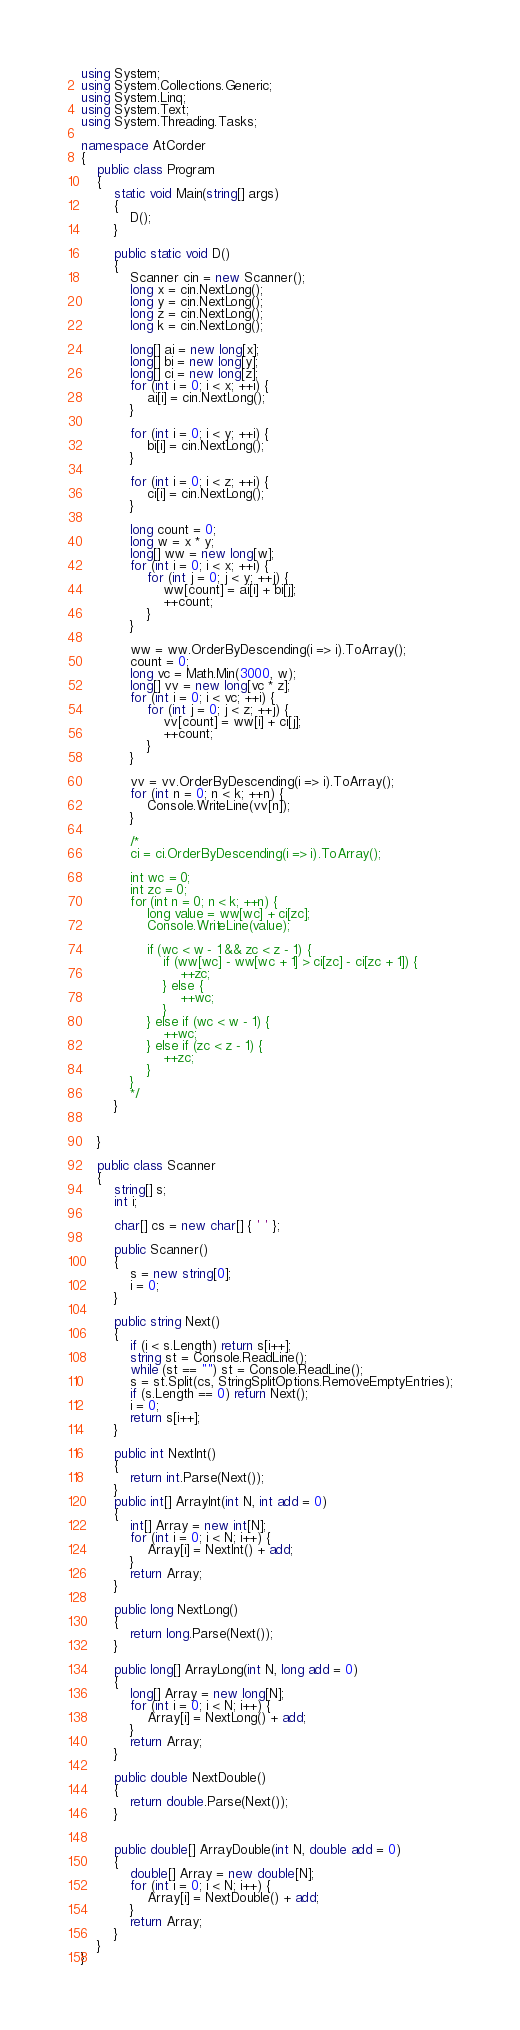Convert code to text. <code><loc_0><loc_0><loc_500><loc_500><_C#_>using System;
using System.Collections.Generic;
using System.Linq;
using System.Text;
using System.Threading.Tasks;

namespace AtCorder
{
	public class Program
	{
		static void Main(string[] args)
		{
			D();
		}

		public static void D()
		{
			Scanner cin = new Scanner();
			long x = cin.NextLong();
			long y = cin.NextLong();
			long z = cin.NextLong();
			long k = cin.NextLong();

			long[] ai = new long[x];
			long[] bi = new long[y];
			long[] ci = new long[z];
			for (int i = 0; i < x; ++i) {
				ai[i] = cin.NextLong();
			}

			for (int i = 0; i < y; ++i) {
				bi[i] = cin.NextLong();
			}

			for (int i = 0; i < z; ++i) {
				ci[i] = cin.NextLong();
			}

			long count = 0;
			long w = x * y;
			long[] ww = new long[w];
			for (int i = 0; i < x; ++i) {
				for (int j = 0; j < y; ++j) {
					ww[count] = ai[i] + bi[j];
					++count;
				}
			}

			ww = ww.OrderByDescending(i => i).ToArray();
			count = 0;
			long vc = Math.Min(3000, w);
			long[] vv = new long[vc * z];
			for (int i = 0; i < vc; ++i) {
				for (int j = 0; j < z; ++j) {
					vv[count] = ww[i] + ci[j];
					++count;
				}
			}

			vv = vv.OrderByDescending(i => i).ToArray();
			for (int n = 0; n < k; ++n) {
				Console.WriteLine(vv[n]);
			}

			/*
			ci = ci.OrderByDescending(i => i).ToArray();

			int wc = 0;
			int zc = 0;
			for (int n = 0; n < k; ++n) {
				long value = ww[wc] + ci[zc];
				Console.WriteLine(value);

				if (wc < w - 1 && zc < z - 1) {
					if (ww[wc] - ww[wc + 1] > ci[zc] - ci[zc + 1]) {
						++zc;
					} else {
						++wc;
					}
				} else if (wc < w - 1) {
					++wc;
				} else if (zc < z - 1) {
					++zc;
				}
			}
			*/
		}

		
	}

	public class Scanner
	{
		string[] s;
		int i;

		char[] cs = new char[] { ' ' };

		public Scanner()
		{
			s = new string[0];
			i = 0;
		}

		public string Next()
		{
			if (i < s.Length) return s[i++];
			string st = Console.ReadLine();
			while (st == "") st = Console.ReadLine();
			s = st.Split(cs, StringSplitOptions.RemoveEmptyEntries);
			if (s.Length == 0) return Next();
			i = 0;
			return s[i++];
		}

		public int NextInt()
		{
			return int.Parse(Next());
		}
		public int[] ArrayInt(int N, int add = 0)
		{
			int[] Array = new int[N];
			for (int i = 0; i < N; i++) {
				Array[i] = NextInt() + add;
			}
			return Array;
		}

		public long NextLong()
		{
			return long.Parse(Next());
		}

		public long[] ArrayLong(int N, long add = 0)
		{
			long[] Array = new long[N];
			for (int i = 0; i < N; i++) {
				Array[i] = NextLong() + add;
			}
			return Array;
		}

		public double NextDouble()
		{
			return double.Parse(Next());
		}


		public double[] ArrayDouble(int N, double add = 0)
		{
			double[] Array = new double[N];
			for (int i = 0; i < N; i++) {
				Array[i] = NextDouble() + add;
			}
			return Array;
		}
	}
}
</code> 